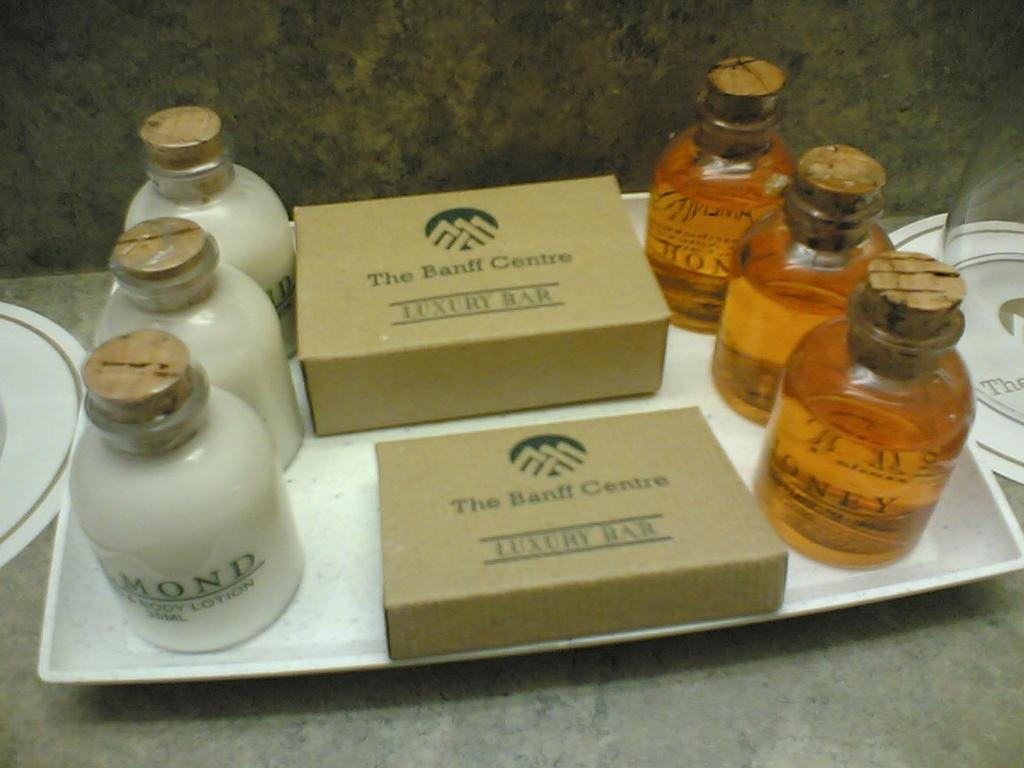<image>
Present a compact description of the photo's key features. Hotel bath products from The Banff Center are on a tray. 